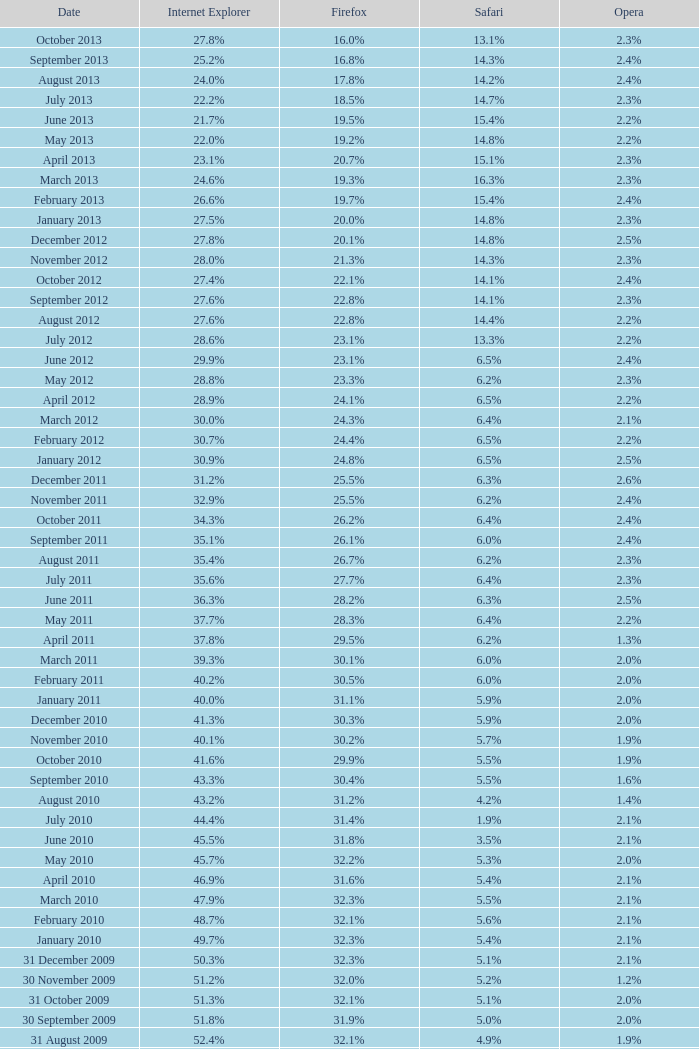What is the firefox value with a 1.9% safari? 31.4%. 